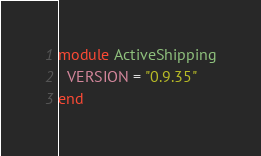Convert code to text. <code><loc_0><loc_0><loc_500><loc_500><_Ruby_>module ActiveShipping
  VERSION = "0.9.35"
end
</code> 